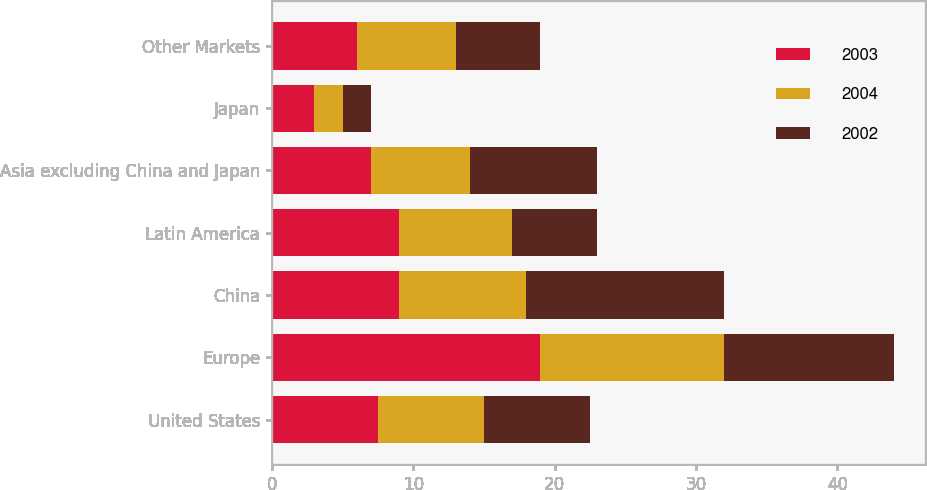Convert chart. <chart><loc_0><loc_0><loc_500><loc_500><stacked_bar_chart><ecel><fcel>United States<fcel>Europe<fcel>China<fcel>Latin America<fcel>Asia excluding China and Japan<fcel>Japan<fcel>Other Markets<nl><fcel>2003<fcel>7.5<fcel>19<fcel>9<fcel>9<fcel>7<fcel>3<fcel>6<nl><fcel>2004<fcel>7.5<fcel>13<fcel>9<fcel>8<fcel>7<fcel>2<fcel>7<nl><fcel>2002<fcel>7.5<fcel>12<fcel>14<fcel>6<fcel>9<fcel>2<fcel>6<nl></chart> 